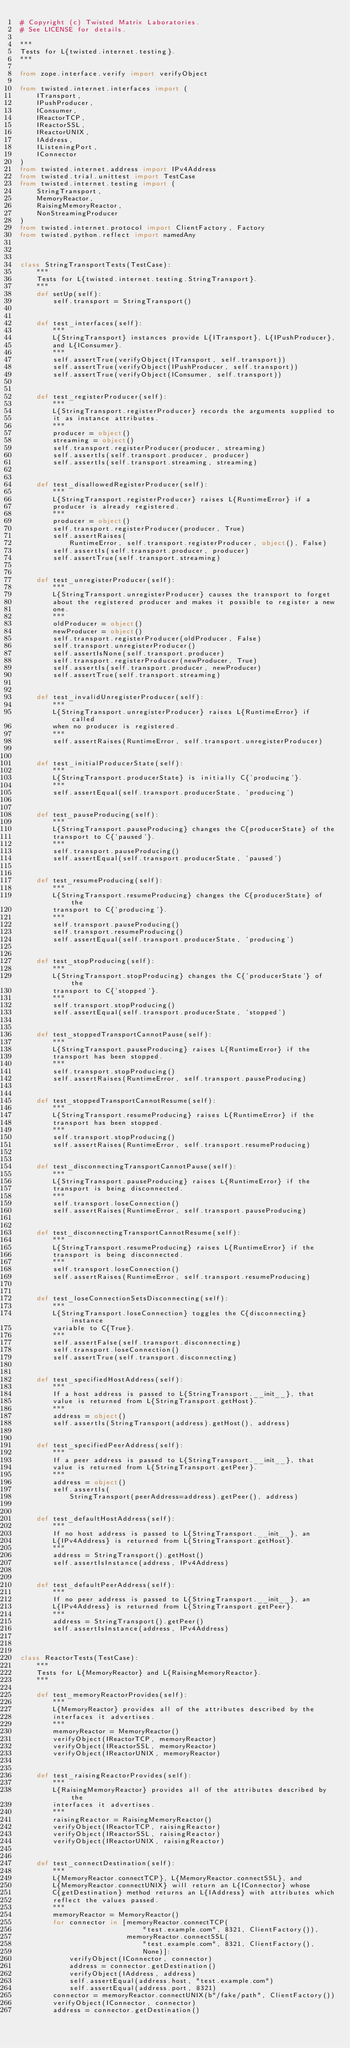Convert code to text. <code><loc_0><loc_0><loc_500><loc_500><_Python_># Copyright (c) Twisted Matrix Laboratories.
# See LICENSE for details.

"""
Tests for L{twisted.internet.testing}.
"""

from zope.interface.verify import verifyObject

from twisted.internet.interfaces import (
    ITransport,
    IPushProducer,
    IConsumer,
    IReactorTCP,
    IReactorSSL,
    IReactorUNIX,
    IAddress,
    IListeningPort,
    IConnector
)
from twisted.internet.address import IPv4Address
from twisted.trial.unittest import TestCase
from twisted.internet.testing import (
    StringTransport,
    MemoryReactor,
    RaisingMemoryReactor,
    NonStreamingProducer
)
from twisted.internet.protocol import ClientFactory, Factory
from twisted.python.reflect import namedAny



class StringTransportTests(TestCase):
    """
    Tests for L{twisted.internet.testing.StringTransport}.
    """
    def setUp(self):
        self.transport = StringTransport()


    def test_interfaces(self):
        """
        L{StringTransport} instances provide L{ITransport}, L{IPushProducer},
        and L{IConsumer}.
        """
        self.assertTrue(verifyObject(ITransport, self.transport))
        self.assertTrue(verifyObject(IPushProducer, self.transport))
        self.assertTrue(verifyObject(IConsumer, self.transport))


    def test_registerProducer(self):
        """
        L{StringTransport.registerProducer} records the arguments supplied to
        it as instance attributes.
        """
        producer = object()
        streaming = object()
        self.transport.registerProducer(producer, streaming)
        self.assertIs(self.transport.producer, producer)
        self.assertIs(self.transport.streaming, streaming)


    def test_disallowedRegisterProducer(self):
        """
        L{StringTransport.registerProducer} raises L{RuntimeError} if a
        producer is already registered.
        """
        producer = object()
        self.transport.registerProducer(producer, True)
        self.assertRaises(
            RuntimeError, self.transport.registerProducer, object(), False)
        self.assertIs(self.transport.producer, producer)
        self.assertTrue(self.transport.streaming)


    def test_unregisterProducer(self):
        """
        L{StringTransport.unregisterProducer} causes the transport to forget
        about the registered producer and makes it possible to register a new
        one.
        """
        oldProducer = object()
        newProducer = object()
        self.transport.registerProducer(oldProducer, False)
        self.transport.unregisterProducer()
        self.assertIsNone(self.transport.producer)
        self.transport.registerProducer(newProducer, True)
        self.assertIs(self.transport.producer, newProducer)
        self.assertTrue(self.transport.streaming)


    def test_invalidUnregisterProducer(self):
        """
        L{StringTransport.unregisterProducer} raises L{RuntimeError} if called
        when no producer is registered.
        """
        self.assertRaises(RuntimeError, self.transport.unregisterProducer)


    def test_initialProducerState(self):
        """
        L{StringTransport.producerState} is initially C{'producing'}.
        """
        self.assertEqual(self.transport.producerState, 'producing')


    def test_pauseProducing(self):
        """
        L{StringTransport.pauseProducing} changes the C{producerState} of the
        transport to C{'paused'}.
        """
        self.transport.pauseProducing()
        self.assertEqual(self.transport.producerState, 'paused')


    def test_resumeProducing(self):
        """
        L{StringTransport.resumeProducing} changes the C{producerState} of the
        transport to C{'producing'}.
        """
        self.transport.pauseProducing()
        self.transport.resumeProducing()
        self.assertEqual(self.transport.producerState, 'producing')


    def test_stopProducing(self):
        """
        L{StringTransport.stopProducing} changes the C{'producerState'} of the
        transport to C{'stopped'}.
        """
        self.transport.stopProducing()
        self.assertEqual(self.transport.producerState, 'stopped')


    def test_stoppedTransportCannotPause(self):
        """
        L{StringTransport.pauseProducing} raises L{RuntimeError} if the
        transport has been stopped.
        """
        self.transport.stopProducing()
        self.assertRaises(RuntimeError, self.transport.pauseProducing)


    def test_stoppedTransportCannotResume(self):
        """
        L{StringTransport.resumeProducing} raises L{RuntimeError} if the
        transport has been stopped.
        """
        self.transport.stopProducing()
        self.assertRaises(RuntimeError, self.transport.resumeProducing)


    def test_disconnectingTransportCannotPause(self):
        """
        L{StringTransport.pauseProducing} raises L{RuntimeError} if the
        transport is being disconnected.
        """
        self.transport.loseConnection()
        self.assertRaises(RuntimeError, self.transport.pauseProducing)


    def test_disconnectingTransportCannotResume(self):
        """
        L{StringTransport.resumeProducing} raises L{RuntimeError} if the
        transport is being disconnected.
        """
        self.transport.loseConnection()
        self.assertRaises(RuntimeError, self.transport.resumeProducing)


    def test_loseConnectionSetsDisconnecting(self):
        """
        L{StringTransport.loseConnection} toggles the C{disconnecting} instance
        variable to C{True}.
        """
        self.assertFalse(self.transport.disconnecting)
        self.transport.loseConnection()
        self.assertTrue(self.transport.disconnecting)


    def test_specifiedHostAddress(self):
        """
        If a host address is passed to L{StringTransport.__init__}, that
        value is returned from L{StringTransport.getHost}.
        """
        address = object()
        self.assertIs(StringTransport(address).getHost(), address)


    def test_specifiedPeerAddress(self):
        """
        If a peer address is passed to L{StringTransport.__init__}, that
        value is returned from L{StringTransport.getPeer}.
        """
        address = object()
        self.assertIs(
            StringTransport(peerAddress=address).getPeer(), address)


    def test_defaultHostAddress(self):
        """
        If no host address is passed to L{StringTransport.__init__}, an
        L{IPv4Address} is returned from L{StringTransport.getHost}.
        """
        address = StringTransport().getHost()
        self.assertIsInstance(address, IPv4Address)


    def test_defaultPeerAddress(self):
        """
        If no peer address is passed to L{StringTransport.__init__}, an
        L{IPv4Address} is returned from L{StringTransport.getPeer}.
        """
        address = StringTransport().getPeer()
        self.assertIsInstance(address, IPv4Address)



class ReactorTests(TestCase):
    """
    Tests for L{MemoryReactor} and L{RaisingMemoryReactor}.
    """

    def test_memoryReactorProvides(self):
        """
        L{MemoryReactor} provides all of the attributes described by the
        interfaces it advertises.
        """
        memoryReactor = MemoryReactor()
        verifyObject(IReactorTCP, memoryReactor)
        verifyObject(IReactorSSL, memoryReactor)
        verifyObject(IReactorUNIX, memoryReactor)


    def test_raisingReactorProvides(self):
        """
        L{RaisingMemoryReactor} provides all of the attributes described by the
        interfaces it advertises.
        """
        raisingReactor = RaisingMemoryReactor()
        verifyObject(IReactorTCP, raisingReactor)
        verifyObject(IReactorSSL, raisingReactor)
        verifyObject(IReactorUNIX, raisingReactor)


    def test_connectDestination(self):
        """
        L{MemoryReactor.connectTCP}, L{MemoryReactor.connectSSL}, and
        L{MemoryReactor.connectUNIX} will return an L{IConnector} whose
        C{getDestination} method returns an L{IAddress} with attributes which
        reflect the values passed.
        """
        memoryReactor = MemoryReactor()
        for connector in [memoryReactor.connectTCP(
                              "test.example.com", 8321, ClientFactory()),
                          memoryReactor.connectSSL(
                              "test.example.com", 8321, ClientFactory(),
                              None)]:
            verifyObject(IConnector, connector)
            address = connector.getDestination()
            verifyObject(IAddress, address)
            self.assertEqual(address.host, "test.example.com")
            self.assertEqual(address.port, 8321)
        connector = memoryReactor.connectUNIX(b"/fake/path", ClientFactory())
        verifyObject(IConnector, connector)
        address = connector.getDestination()</code> 